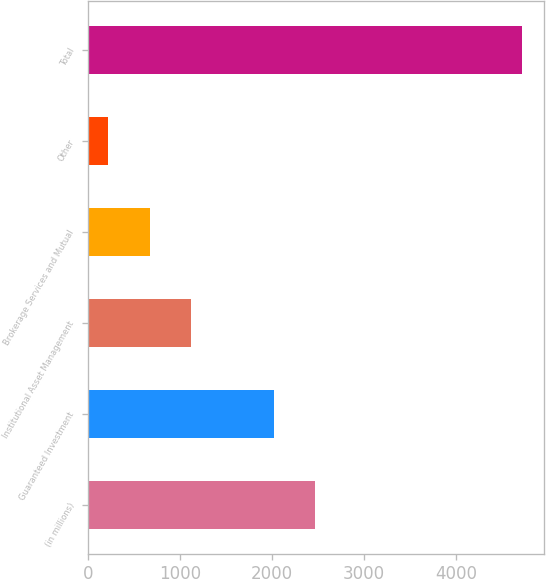Convert chart to OTSL. <chart><loc_0><loc_0><loc_500><loc_500><bar_chart><fcel>(in millions)<fcel>Guaranteed Investment<fcel>Institutional Asset Management<fcel>Brokerage Services and Mutual<fcel>Other<fcel>Total<nl><fcel>2469<fcel>2020<fcel>1122<fcel>673<fcel>224<fcel>4714<nl></chart> 